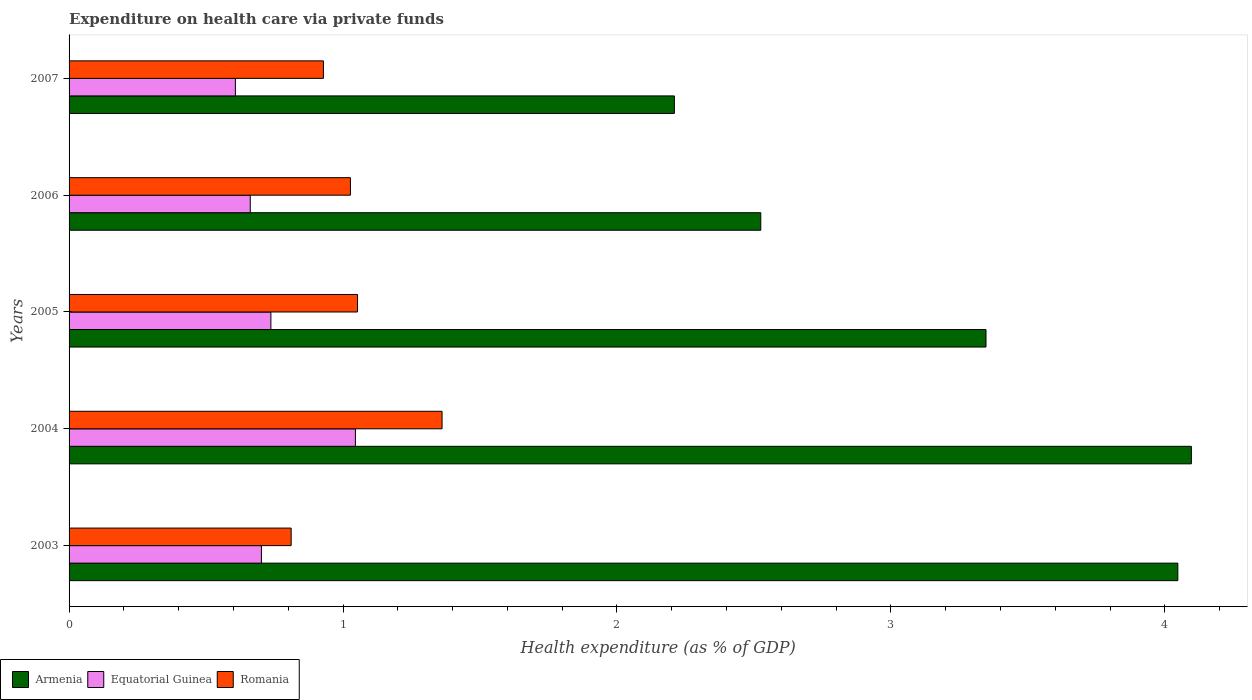Are the number of bars on each tick of the Y-axis equal?
Give a very brief answer. Yes. How many bars are there on the 2nd tick from the top?
Your answer should be compact. 3. How many bars are there on the 4th tick from the bottom?
Ensure brevity in your answer.  3. What is the label of the 4th group of bars from the top?
Offer a very short reply. 2004. What is the expenditure made on health care in Armenia in 2007?
Provide a short and direct response. 2.21. Across all years, what is the maximum expenditure made on health care in Armenia?
Give a very brief answer. 4.1. Across all years, what is the minimum expenditure made on health care in Equatorial Guinea?
Provide a succinct answer. 0.61. In which year was the expenditure made on health care in Armenia maximum?
Keep it short and to the point. 2004. In which year was the expenditure made on health care in Equatorial Guinea minimum?
Offer a very short reply. 2007. What is the total expenditure made on health care in Armenia in the graph?
Make the answer very short. 16.23. What is the difference between the expenditure made on health care in Equatorial Guinea in 2003 and that in 2005?
Your answer should be compact. -0.03. What is the difference between the expenditure made on health care in Equatorial Guinea in 2004 and the expenditure made on health care in Romania in 2003?
Provide a succinct answer. 0.23. What is the average expenditure made on health care in Romania per year?
Provide a succinct answer. 1.04. In the year 2004, what is the difference between the expenditure made on health care in Equatorial Guinea and expenditure made on health care in Romania?
Provide a succinct answer. -0.32. What is the ratio of the expenditure made on health care in Armenia in 2004 to that in 2006?
Give a very brief answer. 1.62. Is the expenditure made on health care in Romania in 2003 less than that in 2005?
Provide a short and direct response. Yes. Is the difference between the expenditure made on health care in Equatorial Guinea in 2003 and 2004 greater than the difference between the expenditure made on health care in Romania in 2003 and 2004?
Offer a terse response. Yes. What is the difference between the highest and the second highest expenditure made on health care in Romania?
Give a very brief answer. 0.31. What is the difference between the highest and the lowest expenditure made on health care in Armenia?
Your answer should be very brief. 1.89. In how many years, is the expenditure made on health care in Armenia greater than the average expenditure made on health care in Armenia taken over all years?
Keep it short and to the point. 3. Is the sum of the expenditure made on health care in Armenia in 2003 and 2004 greater than the maximum expenditure made on health care in Romania across all years?
Your response must be concise. Yes. What does the 3rd bar from the top in 2006 represents?
Offer a terse response. Armenia. What does the 3rd bar from the bottom in 2004 represents?
Your response must be concise. Romania. Is it the case that in every year, the sum of the expenditure made on health care in Armenia and expenditure made on health care in Romania is greater than the expenditure made on health care in Equatorial Guinea?
Provide a short and direct response. Yes. How many bars are there?
Your response must be concise. 15. Are all the bars in the graph horizontal?
Keep it short and to the point. Yes. What is the difference between two consecutive major ticks on the X-axis?
Make the answer very short. 1. Are the values on the major ticks of X-axis written in scientific E-notation?
Your answer should be compact. No. Does the graph contain grids?
Ensure brevity in your answer.  No. Where does the legend appear in the graph?
Your response must be concise. Bottom left. How many legend labels are there?
Provide a short and direct response. 3. What is the title of the graph?
Give a very brief answer. Expenditure on health care via private funds. Does "Congo (Republic)" appear as one of the legend labels in the graph?
Your response must be concise. No. What is the label or title of the X-axis?
Provide a succinct answer. Health expenditure (as % of GDP). What is the label or title of the Y-axis?
Your answer should be very brief. Years. What is the Health expenditure (as % of GDP) of Armenia in 2003?
Your answer should be very brief. 4.05. What is the Health expenditure (as % of GDP) of Equatorial Guinea in 2003?
Your answer should be very brief. 0.7. What is the Health expenditure (as % of GDP) of Romania in 2003?
Offer a very short reply. 0.81. What is the Health expenditure (as % of GDP) of Armenia in 2004?
Your response must be concise. 4.1. What is the Health expenditure (as % of GDP) in Equatorial Guinea in 2004?
Ensure brevity in your answer.  1.05. What is the Health expenditure (as % of GDP) of Romania in 2004?
Make the answer very short. 1.36. What is the Health expenditure (as % of GDP) of Armenia in 2005?
Keep it short and to the point. 3.35. What is the Health expenditure (as % of GDP) in Equatorial Guinea in 2005?
Your response must be concise. 0.74. What is the Health expenditure (as % of GDP) in Romania in 2005?
Ensure brevity in your answer.  1.05. What is the Health expenditure (as % of GDP) in Armenia in 2006?
Your answer should be very brief. 2.52. What is the Health expenditure (as % of GDP) in Equatorial Guinea in 2006?
Offer a terse response. 0.66. What is the Health expenditure (as % of GDP) in Romania in 2006?
Offer a terse response. 1.03. What is the Health expenditure (as % of GDP) of Armenia in 2007?
Offer a very short reply. 2.21. What is the Health expenditure (as % of GDP) in Equatorial Guinea in 2007?
Provide a succinct answer. 0.61. What is the Health expenditure (as % of GDP) of Romania in 2007?
Provide a succinct answer. 0.93. Across all years, what is the maximum Health expenditure (as % of GDP) of Armenia?
Ensure brevity in your answer.  4.1. Across all years, what is the maximum Health expenditure (as % of GDP) in Equatorial Guinea?
Your answer should be compact. 1.05. Across all years, what is the maximum Health expenditure (as % of GDP) of Romania?
Provide a succinct answer. 1.36. Across all years, what is the minimum Health expenditure (as % of GDP) in Armenia?
Offer a terse response. 2.21. Across all years, what is the minimum Health expenditure (as % of GDP) of Equatorial Guinea?
Provide a short and direct response. 0.61. Across all years, what is the minimum Health expenditure (as % of GDP) of Romania?
Keep it short and to the point. 0.81. What is the total Health expenditure (as % of GDP) in Armenia in the graph?
Make the answer very short. 16.23. What is the total Health expenditure (as % of GDP) of Equatorial Guinea in the graph?
Your response must be concise. 3.75. What is the total Health expenditure (as % of GDP) of Romania in the graph?
Give a very brief answer. 5.18. What is the difference between the Health expenditure (as % of GDP) in Armenia in 2003 and that in 2004?
Your answer should be compact. -0.05. What is the difference between the Health expenditure (as % of GDP) in Equatorial Guinea in 2003 and that in 2004?
Make the answer very short. -0.34. What is the difference between the Health expenditure (as % of GDP) in Romania in 2003 and that in 2004?
Your answer should be compact. -0.55. What is the difference between the Health expenditure (as % of GDP) in Armenia in 2003 and that in 2005?
Provide a succinct answer. 0.7. What is the difference between the Health expenditure (as % of GDP) of Equatorial Guinea in 2003 and that in 2005?
Make the answer very short. -0.03. What is the difference between the Health expenditure (as % of GDP) of Romania in 2003 and that in 2005?
Offer a terse response. -0.24. What is the difference between the Health expenditure (as % of GDP) of Armenia in 2003 and that in 2006?
Provide a succinct answer. 1.52. What is the difference between the Health expenditure (as % of GDP) of Equatorial Guinea in 2003 and that in 2006?
Your answer should be compact. 0.04. What is the difference between the Health expenditure (as % of GDP) in Romania in 2003 and that in 2006?
Ensure brevity in your answer.  -0.22. What is the difference between the Health expenditure (as % of GDP) of Armenia in 2003 and that in 2007?
Give a very brief answer. 1.84. What is the difference between the Health expenditure (as % of GDP) of Equatorial Guinea in 2003 and that in 2007?
Provide a short and direct response. 0.1. What is the difference between the Health expenditure (as % of GDP) in Romania in 2003 and that in 2007?
Provide a short and direct response. -0.12. What is the difference between the Health expenditure (as % of GDP) in Armenia in 2004 and that in 2005?
Provide a succinct answer. 0.75. What is the difference between the Health expenditure (as % of GDP) of Equatorial Guinea in 2004 and that in 2005?
Offer a very short reply. 0.31. What is the difference between the Health expenditure (as % of GDP) of Romania in 2004 and that in 2005?
Ensure brevity in your answer.  0.31. What is the difference between the Health expenditure (as % of GDP) of Armenia in 2004 and that in 2006?
Your answer should be very brief. 1.57. What is the difference between the Health expenditure (as % of GDP) of Equatorial Guinea in 2004 and that in 2006?
Your answer should be very brief. 0.38. What is the difference between the Health expenditure (as % of GDP) of Romania in 2004 and that in 2006?
Your answer should be compact. 0.33. What is the difference between the Health expenditure (as % of GDP) in Armenia in 2004 and that in 2007?
Provide a short and direct response. 1.89. What is the difference between the Health expenditure (as % of GDP) in Equatorial Guinea in 2004 and that in 2007?
Make the answer very short. 0.44. What is the difference between the Health expenditure (as % of GDP) of Romania in 2004 and that in 2007?
Provide a short and direct response. 0.43. What is the difference between the Health expenditure (as % of GDP) of Armenia in 2005 and that in 2006?
Make the answer very short. 0.82. What is the difference between the Health expenditure (as % of GDP) of Equatorial Guinea in 2005 and that in 2006?
Ensure brevity in your answer.  0.08. What is the difference between the Health expenditure (as % of GDP) in Romania in 2005 and that in 2006?
Make the answer very short. 0.03. What is the difference between the Health expenditure (as % of GDP) in Armenia in 2005 and that in 2007?
Provide a succinct answer. 1.14. What is the difference between the Health expenditure (as % of GDP) of Equatorial Guinea in 2005 and that in 2007?
Your response must be concise. 0.13. What is the difference between the Health expenditure (as % of GDP) in Romania in 2005 and that in 2007?
Provide a succinct answer. 0.12. What is the difference between the Health expenditure (as % of GDP) of Armenia in 2006 and that in 2007?
Keep it short and to the point. 0.32. What is the difference between the Health expenditure (as % of GDP) of Equatorial Guinea in 2006 and that in 2007?
Provide a succinct answer. 0.05. What is the difference between the Health expenditure (as % of GDP) of Romania in 2006 and that in 2007?
Your response must be concise. 0.1. What is the difference between the Health expenditure (as % of GDP) in Armenia in 2003 and the Health expenditure (as % of GDP) in Equatorial Guinea in 2004?
Give a very brief answer. 3. What is the difference between the Health expenditure (as % of GDP) of Armenia in 2003 and the Health expenditure (as % of GDP) of Romania in 2004?
Offer a very short reply. 2.69. What is the difference between the Health expenditure (as % of GDP) in Equatorial Guinea in 2003 and the Health expenditure (as % of GDP) in Romania in 2004?
Make the answer very short. -0.66. What is the difference between the Health expenditure (as % of GDP) in Armenia in 2003 and the Health expenditure (as % of GDP) in Equatorial Guinea in 2005?
Your response must be concise. 3.31. What is the difference between the Health expenditure (as % of GDP) of Armenia in 2003 and the Health expenditure (as % of GDP) of Romania in 2005?
Keep it short and to the point. 2.99. What is the difference between the Health expenditure (as % of GDP) in Equatorial Guinea in 2003 and the Health expenditure (as % of GDP) in Romania in 2005?
Keep it short and to the point. -0.35. What is the difference between the Health expenditure (as % of GDP) of Armenia in 2003 and the Health expenditure (as % of GDP) of Equatorial Guinea in 2006?
Offer a very short reply. 3.39. What is the difference between the Health expenditure (as % of GDP) in Armenia in 2003 and the Health expenditure (as % of GDP) in Romania in 2006?
Keep it short and to the point. 3.02. What is the difference between the Health expenditure (as % of GDP) of Equatorial Guinea in 2003 and the Health expenditure (as % of GDP) of Romania in 2006?
Your answer should be compact. -0.32. What is the difference between the Health expenditure (as % of GDP) of Armenia in 2003 and the Health expenditure (as % of GDP) of Equatorial Guinea in 2007?
Make the answer very short. 3.44. What is the difference between the Health expenditure (as % of GDP) in Armenia in 2003 and the Health expenditure (as % of GDP) in Romania in 2007?
Make the answer very short. 3.12. What is the difference between the Health expenditure (as % of GDP) in Equatorial Guinea in 2003 and the Health expenditure (as % of GDP) in Romania in 2007?
Provide a short and direct response. -0.23. What is the difference between the Health expenditure (as % of GDP) of Armenia in 2004 and the Health expenditure (as % of GDP) of Equatorial Guinea in 2005?
Your answer should be compact. 3.36. What is the difference between the Health expenditure (as % of GDP) in Armenia in 2004 and the Health expenditure (as % of GDP) in Romania in 2005?
Provide a short and direct response. 3.04. What is the difference between the Health expenditure (as % of GDP) of Equatorial Guinea in 2004 and the Health expenditure (as % of GDP) of Romania in 2005?
Offer a very short reply. -0.01. What is the difference between the Health expenditure (as % of GDP) in Armenia in 2004 and the Health expenditure (as % of GDP) in Equatorial Guinea in 2006?
Offer a terse response. 3.44. What is the difference between the Health expenditure (as % of GDP) in Armenia in 2004 and the Health expenditure (as % of GDP) in Romania in 2006?
Your answer should be very brief. 3.07. What is the difference between the Health expenditure (as % of GDP) of Equatorial Guinea in 2004 and the Health expenditure (as % of GDP) of Romania in 2006?
Make the answer very short. 0.02. What is the difference between the Health expenditure (as % of GDP) of Armenia in 2004 and the Health expenditure (as % of GDP) of Equatorial Guinea in 2007?
Keep it short and to the point. 3.49. What is the difference between the Health expenditure (as % of GDP) of Armenia in 2004 and the Health expenditure (as % of GDP) of Romania in 2007?
Give a very brief answer. 3.17. What is the difference between the Health expenditure (as % of GDP) in Equatorial Guinea in 2004 and the Health expenditure (as % of GDP) in Romania in 2007?
Your response must be concise. 0.12. What is the difference between the Health expenditure (as % of GDP) in Armenia in 2005 and the Health expenditure (as % of GDP) in Equatorial Guinea in 2006?
Keep it short and to the point. 2.69. What is the difference between the Health expenditure (as % of GDP) in Armenia in 2005 and the Health expenditure (as % of GDP) in Romania in 2006?
Make the answer very short. 2.32. What is the difference between the Health expenditure (as % of GDP) of Equatorial Guinea in 2005 and the Health expenditure (as % of GDP) of Romania in 2006?
Offer a terse response. -0.29. What is the difference between the Health expenditure (as % of GDP) in Armenia in 2005 and the Health expenditure (as % of GDP) in Equatorial Guinea in 2007?
Keep it short and to the point. 2.74. What is the difference between the Health expenditure (as % of GDP) in Armenia in 2005 and the Health expenditure (as % of GDP) in Romania in 2007?
Make the answer very short. 2.42. What is the difference between the Health expenditure (as % of GDP) in Equatorial Guinea in 2005 and the Health expenditure (as % of GDP) in Romania in 2007?
Make the answer very short. -0.19. What is the difference between the Health expenditure (as % of GDP) in Armenia in 2006 and the Health expenditure (as % of GDP) in Equatorial Guinea in 2007?
Your answer should be compact. 1.92. What is the difference between the Health expenditure (as % of GDP) in Armenia in 2006 and the Health expenditure (as % of GDP) in Romania in 2007?
Provide a short and direct response. 1.6. What is the difference between the Health expenditure (as % of GDP) in Equatorial Guinea in 2006 and the Health expenditure (as % of GDP) in Romania in 2007?
Your answer should be compact. -0.27. What is the average Health expenditure (as % of GDP) in Armenia per year?
Your answer should be compact. 3.25. What is the average Health expenditure (as % of GDP) in Equatorial Guinea per year?
Your response must be concise. 0.75. What is the average Health expenditure (as % of GDP) of Romania per year?
Make the answer very short. 1.04. In the year 2003, what is the difference between the Health expenditure (as % of GDP) of Armenia and Health expenditure (as % of GDP) of Equatorial Guinea?
Provide a short and direct response. 3.35. In the year 2003, what is the difference between the Health expenditure (as % of GDP) in Armenia and Health expenditure (as % of GDP) in Romania?
Offer a very short reply. 3.24. In the year 2003, what is the difference between the Health expenditure (as % of GDP) of Equatorial Guinea and Health expenditure (as % of GDP) of Romania?
Ensure brevity in your answer.  -0.11. In the year 2004, what is the difference between the Health expenditure (as % of GDP) of Armenia and Health expenditure (as % of GDP) of Equatorial Guinea?
Offer a very short reply. 3.05. In the year 2004, what is the difference between the Health expenditure (as % of GDP) of Armenia and Health expenditure (as % of GDP) of Romania?
Your answer should be very brief. 2.74. In the year 2004, what is the difference between the Health expenditure (as % of GDP) in Equatorial Guinea and Health expenditure (as % of GDP) in Romania?
Make the answer very short. -0.32. In the year 2005, what is the difference between the Health expenditure (as % of GDP) of Armenia and Health expenditure (as % of GDP) of Equatorial Guinea?
Make the answer very short. 2.61. In the year 2005, what is the difference between the Health expenditure (as % of GDP) in Armenia and Health expenditure (as % of GDP) in Romania?
Make the answer very short. 2.29. In the year 2005, what is the difference between the Health expenditure (as % of GDP) in Equatorial Guinea and Health expenditure (as % of GDP) in Romania?
Make the answer very short. -0.32. In the year 2006, what is the difference between the Health expenditure (as % of GDP) of Armenia and Health expenditure (as % of GDP) of Equatorial Guinea?
Offer a very short reply. 1.86. In the year 2006, what is the difference between the Health expenditure (as % of GDP) of Armenia and Health expenditure (as % of GDP) of Romania?
Provide a succinct answer. 1.5. In the year 2006, what is the difference between the Health expenditure (as % of GDP) in Equatorial Guinea and Health expenditure (as % of GDP) in Romania?
Ensure brevity in your answer.  -0.37. In the year 2007, what is the difference between the Health expenditure (as % of GDP) in Armenia and Health expenditure (as % of GDP) in Equatorial Guinea?
Offer a very short reply. 1.6. In the year 2007, what is the difference between the Health expenditure (as % of GDP) in Armenia and Health expenditure (as % of GDP) in Romania?
Your answer should be compact. 1.28. In the year 2007, what is the difference between the Health expenditure (as % of GDP) in Equatorial Guinea and Health expenditure (as % of GDP) in Romania?
Offer a very short reply. -0.32. What is the ratio of the Health expenditure (as % of GDP) of Armenia in 2003 to that in 2004?
Your response must be concise. 0.99. What is the ratio of the Health expenditure (as % of GDP) of Equatorial Guinea in 2003 to that in 2004?
Your answer should be very brief. 0.67. What is the ratio of the Health expenditure (as % of GDP) in Romania in 2003 to that in 2004?
Your answer should be compact. 0.6. What is the ratio of the Health expenditure (as % of GDP) of Armenia in 2003 to that in 2005?
Provide a succinct answer. 1.21. What is the ratio of the Health expenditure (as % of GDP) in Equatorial Guinea in 2003 to that in 2005?
Provide a succinct answer. 0.95. What is the ratio of the Health expenditure (as % of GDP) in Romania in 2003 to that in 2005?
Make the answer very short. 0.77. What is the ratio of the Health expenditure (as % of GDP) of Armenia in 2003 to that in 2006?
Ensure brevity in your answer.  1.6. What is the ratio of the Health expenditure (as % of GDP) in Equatorial Guinea in 2003 to that in 2006?
Keep it short and to the point. 1.06. What is the ratio of the Health expenditure (as % of GDP) in Romania in 2003 to that in 2006?
Provide a short and direct response. 0.79. What is the ratio of the Health expenditure (as % of GDP) of Armenia in 2003 to that in 2007?
Ensure brevity in your answer.  1.83. What is the ratio of the Health expenditure (as % of GDP) of Equatorial Guinea in 2003 to that in 2007?
Keep it short and to the point. 1.16. What is the ratio of the Health expenditure (as % of GDP) of Romania in 2003 to that in 2007?
Keep it short and to the point. 0.87. What is the ratio of the Health expenditure (as % of GDP) of Armenia in 2004 to that in 2005?
Offer a very short reply. 1.22. What is the ratio of the Health expenditure (as % of GDP) of Equatorial Guinea in 2004 to that in 2005?
Provide a succinct answer. 1.42. What is the ratio of the Health expenditure (as % of GDP) in Romania in 2004 to that in 2005?
Give a very brief answer. 1.29. What is the ratio of the Health expenditure (as % of GDP) in Armenia in 2004 to that in 2006?
Give a very brief answer. 1.62. What is the ratio of the Health expenditure (as % of GDP) of Equatorial Guinea in 2004 to that in 2006?
Provide a short and direct response. 1.58. What is the ratio of the Health expenditure (as % of GDP) of Romania in 2004 to that in 2006?
Your response must be concise. 1.33. What is the ratio of the Health expenditure (as % of GDP) in Armenia in 2004 to that in 2007?
Your answer should be very brief. 1.85. What is the ratio of the Health expenditure (as % of GDP) of Equatorial Guinea in 2004 to that in 2007?
Your answer should be very brief. 1.72. What is the ratio of the Health expenditure (as % of GDP) in Romania in 2004 to that in 2007?
Give a very brief answer. 1.47. What is the ratio of the Health expenditure (as % of GDP) in Armenia in 2005 to that in 2006?
Provide a short and direct response. 1.33. What is the ratio of the Health expenditure (as % of GDP) in Equatorial Guinea in 2005 to that in 2006?
Make the answer very short. 1.11. What is the ratio of the Health expenditure (as % of GDP) of Romania in 2005 to that in 2006?
Give a very brief answer. 1.03. What is the ratio of the Health expenditure (as % of GDP) in Armenia in 2005 to that in 2007?
Give a very brief answer. 1.51. What is the ratio of the Health expenditure (as % of GDP) of Equatorial Guinea in 2005 to that in 2007?
Your answer should be very brief. 1.21. What is the ratio of the Health expenditure (as % of GDP) in Romania in 2005 to that in 2007?
Offer a very short reply. 1.13. What is the ratio of the Health expenditure (as % of GDP) in Armenia in 2006 to that in 2007?
Offer a terse response. 1.14. What is the ratio of the Health expenditure (as % of GDP) in Equatorial Guinea in 2006 to that in 2007?
Offer a terse response. 1.09. What is the ratio of the Health expenditure (as % of GDP) of Romania in 2006 to that in 2007?
Keep it short and to the point. 1.11. What is the difference between the highest and the second highest Health expenditure (as % of GDP) of Armenia?
Make the answer very short. 0.05. What is the difference between the highest and the second highest Health expenditure (as % of GDP) in Equatorial Guinea?
Your answer should be compact. 0.31. What is the difference between the highest and the second highest Health expenditure (as % of GDP) in Romania?
Offer a terse response. 0.31. What is the difference between the highest and the lowest Health expenditure (as % of GDP) of Armenia?
Provide a short and direct response. 1.89. What is the difference between the highest and the lowest Health expenditure (as % of GDP) in Equatorial Guinea?
Offer a very short reply. 0.44. What is the difference between the highest and the lowest Health expenditure (as % of GDP) in Romania?
Offer a terse response. 0.55. 